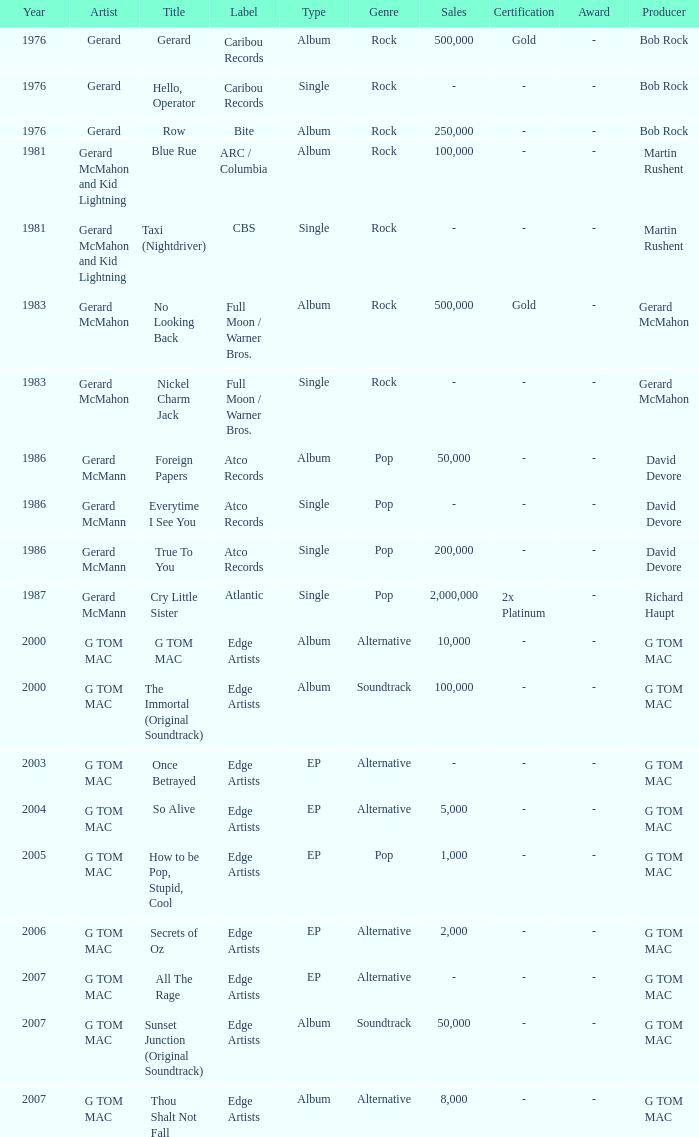Name the Year which has a Label of atco records and a Type of album? Question 2 1986.0. 